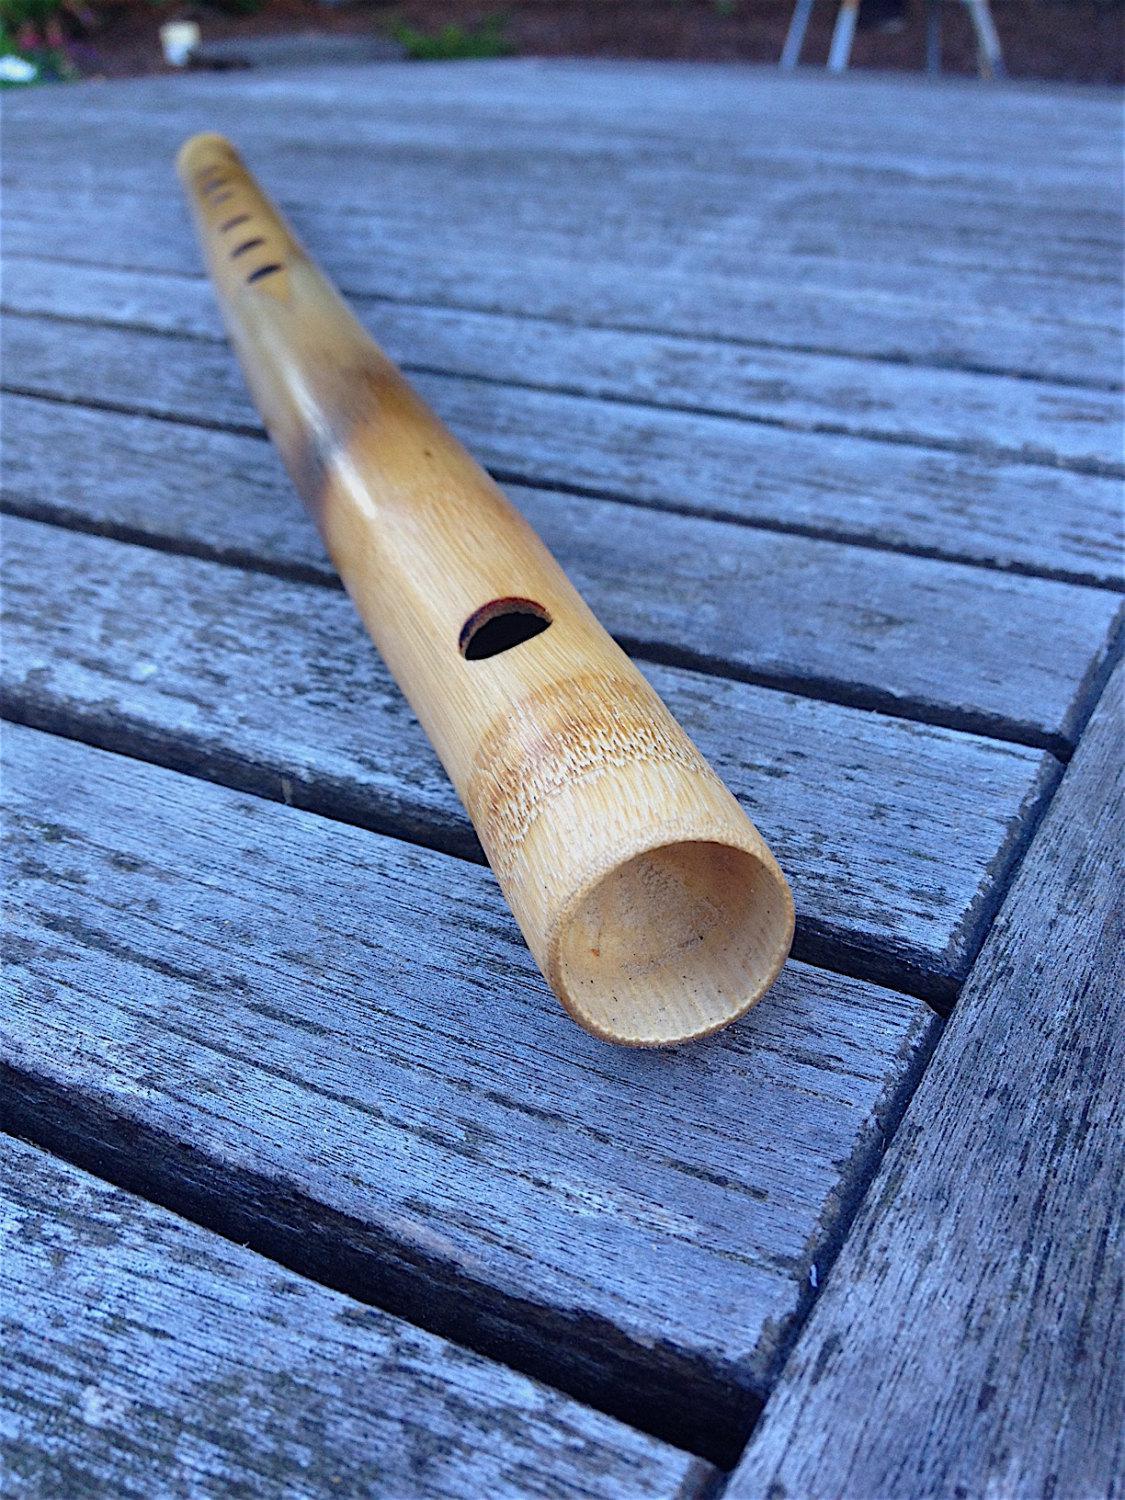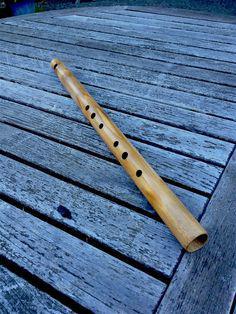The first image is the image on the left, the second image is the image on the right. Assess this claim about the two images: "At least 2 flutes are laying on a wood plank table.". Correct or not? Answer yes or no. Yes. The first image is the image on the left, the second image is the image on the right. Analyze the images presented: Is the assertion "There are exactly two flutes." valid? Answer yes or no. Yes. 